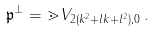<formula> <loc_0><loc_0><loc_500><loc_500>\mathfrak { p } ^ { \perp } = \mathbb { m } { V } _ { 2 ( k ^ { 2 } + l k + l ^ { 2 } ) , 0 } \, .</formula> 